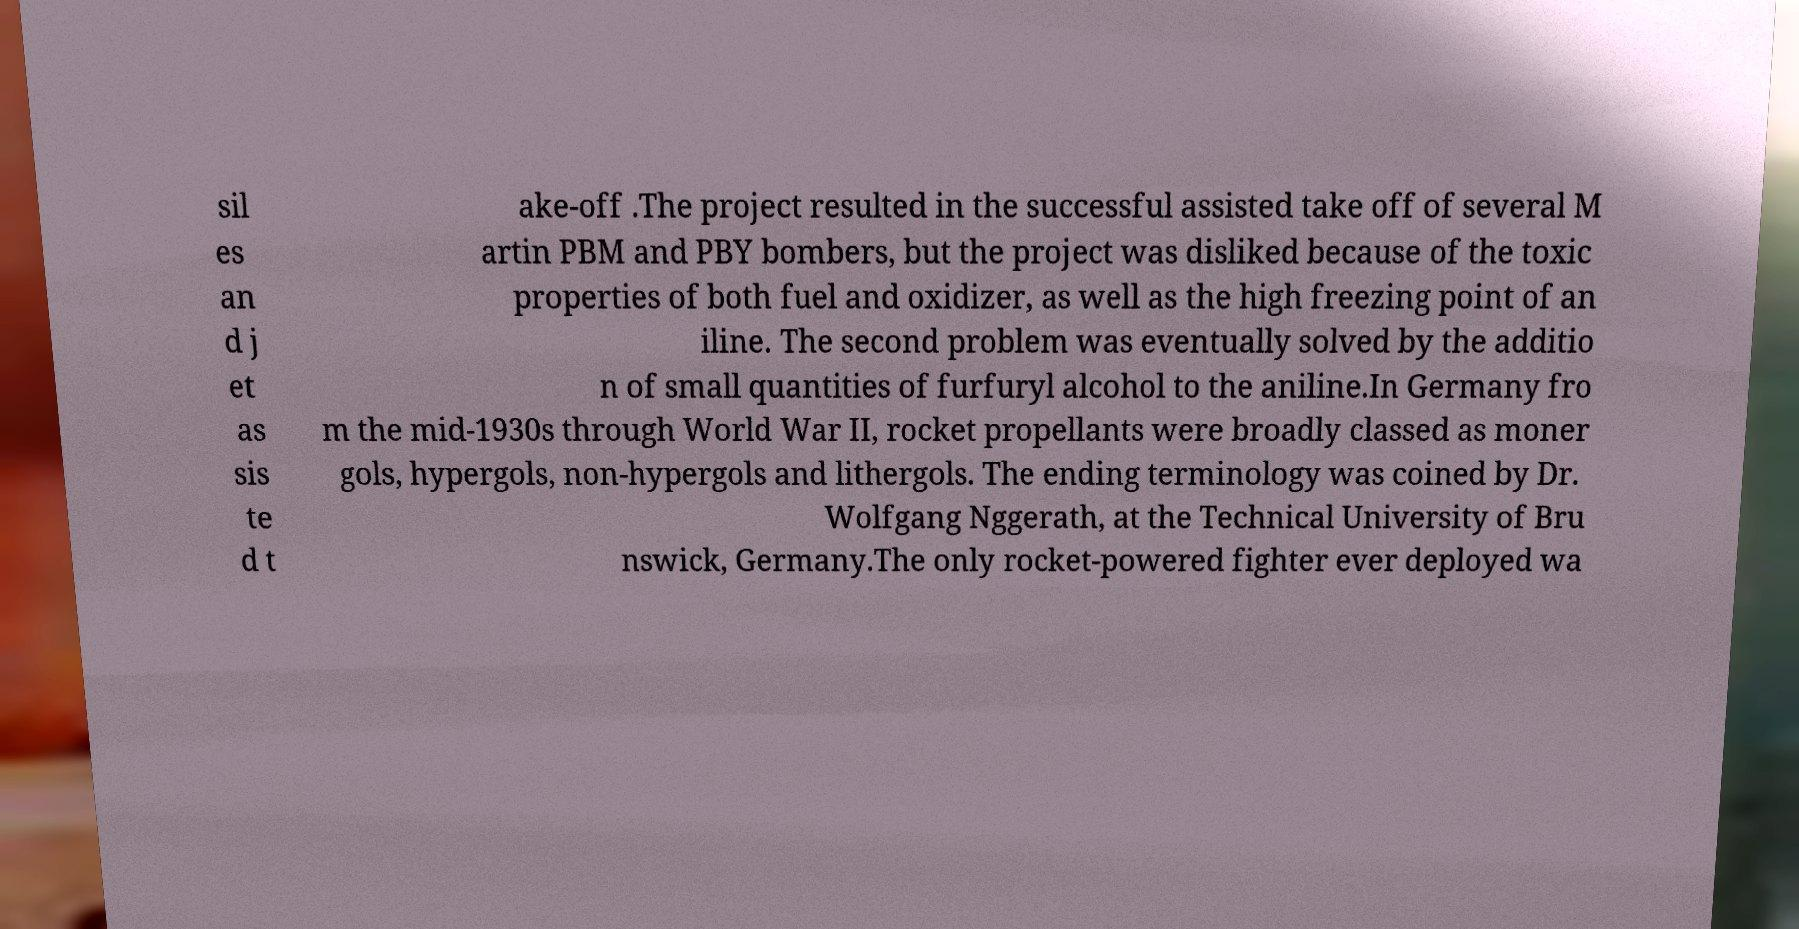Can you read and provide the text displayed in the image?This photo seems to have some interesting text. Can you extract and type it out for me? sil es an d j et as sis te d t ake-off .The project resulted in the successful assisted take off of several M artin PBM and PBY bombers, but the project was disliked because of the toxic properties of both fuel and oxidizer, as well as the high freezing point of an iline. The second problem was eventually solved by the additio n of small quantities of furfuryl alcohol to the aniline.In Germany fro m the mid-1930s through World War II, rocket propellants were broadly classed as moner gols, hypergols, non-hypergols and lithergols. The ending terminology was coined by Dr. Wolfgang Nggerath, at the Technical University of Bru nswick, Germany.The only rocket-powered fighter ever deployed wa 